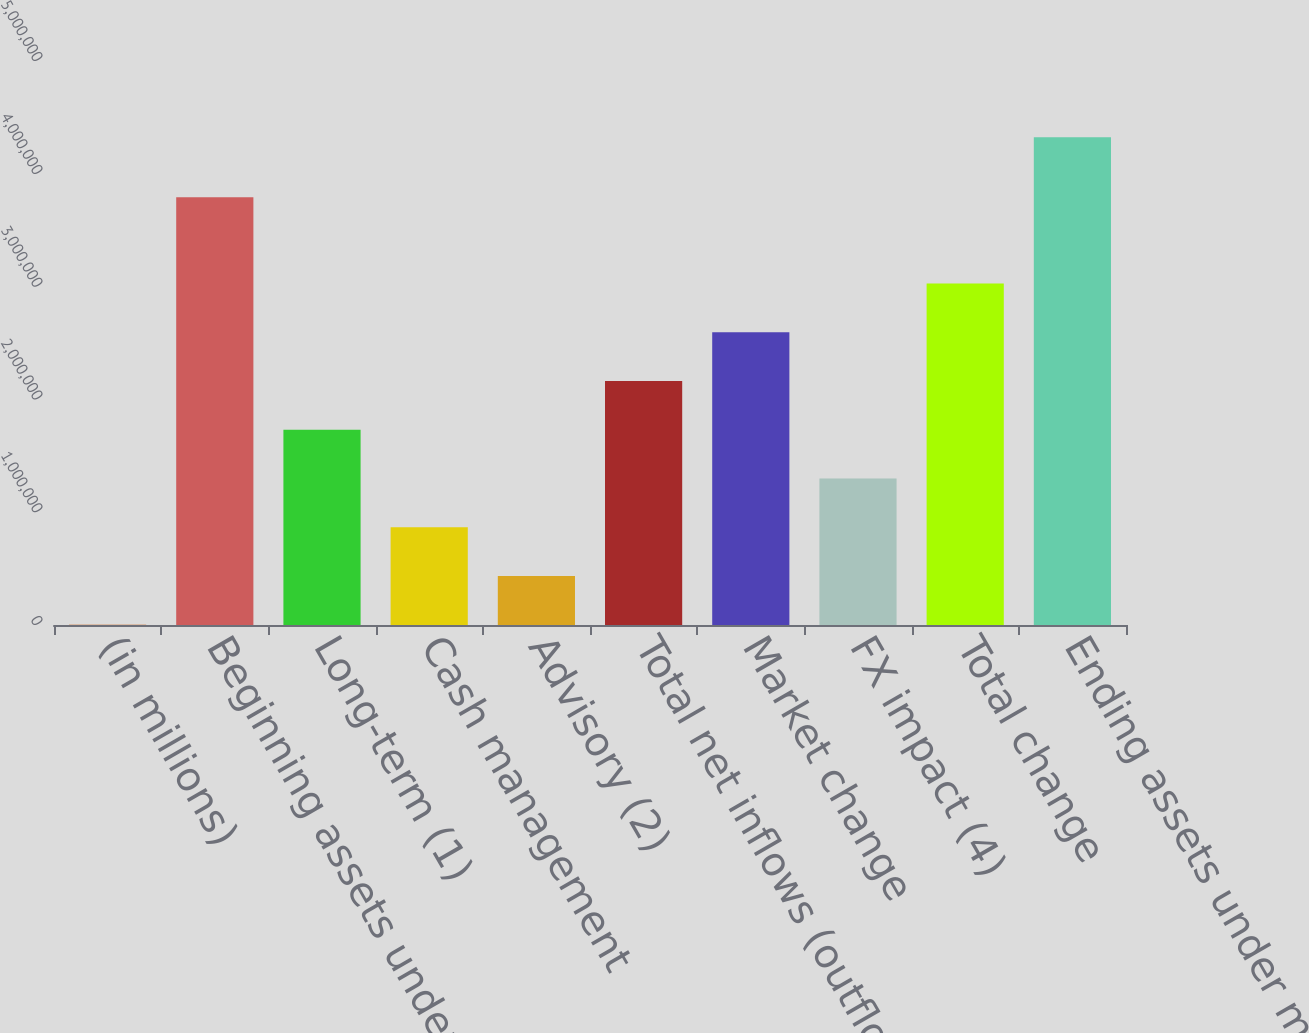Convert chart to OTSL. <chart><loc_0><loc_0><loc_500><loc_500><bar_chart><fcel>(in millions)<fcel>Beginning assets under<fcel>Long-term (1)<fcel>Cash management<fcel>Advisory (2)<fcel>Total net inflows (outflows)<fcel>Market change<fcel>FX impact (4)<fcel>Total change<fcel>Ending assets under management<nl><fcel>2013<fcel>3.79159e+06<fcel>1.73084e+06<fcel>866428<fcel>434220<fcel>2.16305e+06<fcel>2.59526e+06<fcel>1.29864e+06<fcel>3.02747e+06<fcel>4.32409e+06<nl></chart> 